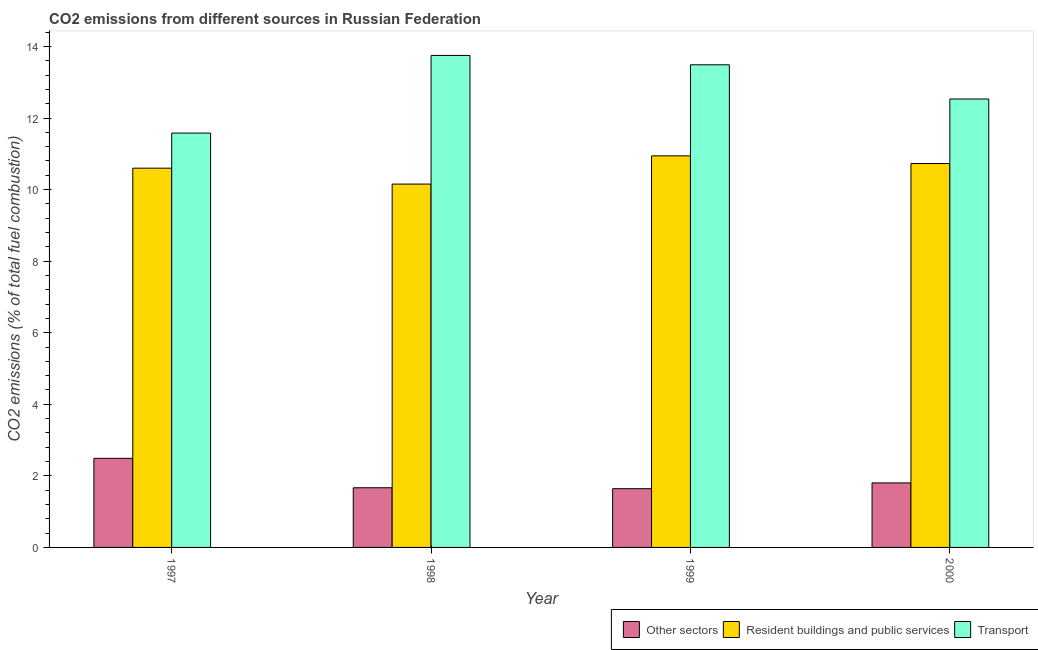How many groups of bars are there?
Your answer should be very brief. 4. How many bars are there on the 3rd tick from the left?
Your response must be concise. 3. How many bars are there on the 2nd tick from the right?
Your answer should be very brief. 3. In how many cases, is the number of bars for a given year not equal to the number of legend labels?
Provide a short and direct response. 0. What is the percentage of co2 emissions from other sectors in 1997?
Keep it short and to the point. 2.49. Across all years, what is the maximum percentage of co2 emissions from transport?
Provide a succinct answer. 13.75. Across all years, what is the minimum percentage of co2 emissions from other sectors?
Provide a succinct answer. 1.64. What is the total percentage of co2 emissions from other sectors in the graph?
Keep it short and to the point. 7.6. What is the difference between the percentage of co2 emissions from resident buildings and public services in 1998 and that in 2000?
Make the answer very short. -0.57. What is the difference between the percentage of co2 emissions from transport in 2000 and the percentage of co2 emissions from resident buildings and public services in 1997?
Keep it short and to the point. 0.95. What is the average percentage of co2 emissions from other sectors per year?
Your answer should be very brief. 1.9. In how many years, is the percentage of co2 emissions from resident buildings and public services greater than 11.6 %?
Offer a terse response. 0. What is the ratio of the percentage of co2 emissions from transport in 1997 to that in 2000?
Give a very brief answer. 0.92. Is the percentage of co2 emissions from other sectors in 1997 less than that in 1998?
Offer a very short reply. No. Is the difference between the percentage of co2 emissions from resident buildings and public services in 1997 and 1998 greater than the difference between the percentage of co2 emissions from transport in 1997 and 1998?
Ensure brevity in your answer.  No. What is the difference between the highest and the second highest percentage of co2 emissions from other sectors?
Your answer should be compact. 0.69. What is the difference between the highest and the lowest percentage of co2 emissions from other sectors?
Ensure brevity in your answer.  0.85. What does the 1st bar from the left in 2000 represents?
Provide a succinct answer. Other sectors. What does the 2nd bar from the right in 2000 represents?
Provide a succinct answer. Resident buildings and public services. Are all the bars in the graph horizontal?
Give a very brief answer. No. How many years are there in the graph?
Provide a succinct answer. 4. Are the values on the major ticks of Y-axis written in scientific E-notation?
Make the answer very short. No. Does the graph contain grids?
Ensure brevity in your answer.  No. Where does the legend appear in the graph?
Make the answer very short. Bottom right. How many legend labels are there?
Offer a very short reply. 3. How are the legend labels stacked?
Ensure brevity in your answer.  Horizontal. What is the title of the graph?
Your answer should be very brief. CO2 emissions from different sources in Russian Federation. What is the label or title of the X-axis?
Offer a terse response. Year. What is the label or title of the Y-axis?
Provide a short and direct response. CO2 emissions (% of total fuel combustion). What is the CO2 emissions (% of total fuel combustion) in Other sectors in 1997?
Your response must be concise. 2.49. What is the CO2 emissions (% of total fuel combustion) of Resident buildings and public services in 1997?
Provide a succinct answer. 10.6. What is the CO2 emissions (% of total fuel combustion) in Transport in 1997?
Give a very brief answer. 11.58. What is the CO2 emissions (% of total fuel combustion) of Other sectors in 1998?
Offer a terse response. 1.67. What is the CO2 emissions (% of total fuel combustion) in Resident buildings and public services in 1998?
Your answer should be compact. 10.15. What is the CO2 emissions (% of total fuel combustion) in Transport in 1998?
Keep it short and to the point. 13.75. What is the CO2 emissions (% of total fuel combustion) in Other sectors in 1999?
Ensure brevity in your answer.  1.64. What is the CO2 emissions (% of total fuel combustion) of Resident buildings and public services in 1999?
Offer a very short reply. 10.94. What is the CO2 emissions (% of total fuel combustion) of Transport in 1999?
Provide a short and direct response. 13.49. What is the CO2 emissions (% of total fuel combustion) of Other sectors in 2000?
Make the answer very short. 1.8. What is the CO2 emissions (% of total fuel combustion) in Resident buildings and public services in 2000?
Provide a short and direct response. 10.73. What is the CO2 emissions (% of total fuel combustion) in Transport in 2000?
Your response must be concise. 12.53. Across all years, what is the maximum CO2 emissions (% of total fuel combustion) in Other sectors?
Your answer should be compact. 2.49. Across all years, what is the maximum CO2 emissions (% of total fuel combustion) of Resident buildings and public services?
Make the answer very short. 10.94. Across all years, what is the maximum CO2 emissions (% of total fuel combustion) of Transport?
Your response must be concise. 13.75. Across all years, what is the minimum CO2 emissions (% of total fuel combustion) of Other sectors?
Ensure brevity in your answer.  1.64. Across all years, what is the minimum CO2 emissions (% of total fuel combustion) of Resident buildings and public services?
Offer a terse response. 10.15. Across all years, what is the minimum CO2 emissions (% of total fuel combustion) of Transport?
Keep it short and to the point. 11.58. What is the total CO2 emissions (% of total fuel combustion) in Other sectors in the graph?
Your answer should be compact. 7.6. What is the total CO2 emissions (% of total fuel combustion) in Resident buildings and public services in the graph?
Make the answer very short. 42.42. What is the total CO2 emissions (% of total fuel combustion) of Transport in the graph?
Offer a very short reply. 51.35. What is the difference between the CO2 emissions (% of total fuel combustion) in Other sectors in 1997 and that in 1998?
Keep it short and to the point. 0.82. What is the difference between the CO2 emissions (% of total fuel combustion) in Resident buildings and public services in 1997 and that in 1998?
Give a very brief answer. 0.44. What is the difference between the CO2 emissions (% of total fuel combustion) in Transport in 1997 and that in 1998?
Offer a terse response. -2.17. What is the difference between the CO2 emissions (% of total fuel combustion) of Other sectors in 1997 and that in 1999?
Your answer should be very brief. 0.85. What is the difference between the CO2 emissions (% of total fuel combustion) in Resident buildings and public services in 1997 and that in 1999?
Offer a terse response. -0.34. What is the difference between the CO2 emissions (% of total fuel combustion) in Transport in 1997 and that in 1999?
Your answer should be compact. -1.91. What is the difference between the CO2 emissions (% of total fuel combustion) of Other sectors in 1997 and that in 2000?
Give a very brief answer. 0.69. What is the difference between the CO2 emissions (% of total fuel combustion) of Resident buildings and public services in 1997 and that in 2000?
Provide a short and direct response. -0.13. What is the difference between the CO2 emissions (% of total fuel combustion) in Transport in 1997 and that in 2000?
Offer a terse response. -0.95. What is the difference between the CO2 emissions (% of total fuel combustion) of Other sectors in 1998 and that in 1999?
Your response must be concise. 0.03. What is the difference between the CO2 emissions (% of total fuel combustion) of Resident buildings and public services in 1998 and that in 1999?
Provide a succinct answer. -0.79. What is the difference between the CO2 emissions (% of total fuel combustion) in Transport in 1998 and that in 1999?
Provide a short and direct response. 0.26. What is the difference between the CO2 emissions (% of total fuel combustion) of Other sectors in 1998 and that in 2000?
Provide a short and direct response. -0.14. What is the difference between the CO2 emissions (% of total fuel combustion) of Resident buildings and public services in 1998 and that in 2000?
Provide a short and direct response. -0.57. What is the difference between the CO2 emissions (% of total fuel combustion) in Transport in 1998 and that in 2000?
Your response must be concise. 1.22. What is the difference between the CO2 emissions (% of total fuel combustion) in Other sectors in 1999 and that in 2000?
Keep it short and to the point. -0.16. What is the difference between the CO2 emissions (% of total fuel combustion) in Resident buildings and public services in 1999 and that in 2000?
Ensure brevity in your answer.  0.21. What is the difference between the CO2 emissions (% of total fuel combustion) of Transport in 1999 and that in 2000?
Ensure brevity in your answer.  0.96. What is the difference between the CO2 emissions (% of total fuel combustion) in Other sectors in 1997 and the CO2 emissions (% of total fuel combustion) in Resident buildings and public services in 1998?
Your response must be concise. -7.66. What is the difference between the CO2 emissions (% of total fuel combustion) of Other sectors in 1997 and the CO2 emissions (% of total fuel combustion) of Transport in 1998?
Your answer should be very brief. -11.26. What is the difference between the CO2 emissions (% of total fuel combustion) in Resident buildings and public services in 1997 and the CO2 emissions (% of total fuel combustion) in Transport in 1998?
Offer a very short reply. -3.15. What is the difference between the CO2 emissions (% of total fuel combustion) in Other sectors in 1997 and the CO2 emissions (% of total fuel combustion) in Resident buildings and public services in 1999?
Keep it short and to the point. -8.45. What is the difference between the CO2 emissions (% of total fuel combustion) in Other sectors in 1997 and the CO2 emissions (% of total fuel combustion) in Transport in 1999?
Provide a short and direct response. -11. What is the difference between the CO2 emissions (% of total fuel combustion) in Resident buildings and public services in 1997 and the CO2 emissions (% of total fuel combustion) in Transport in 1999?
Ensure brevity in your answer.  -2.89. What is the difference between the CO2 emissions (% of total fuel combustion) in Other sectors in 1997 and the CO2 emissions (% of total fuel combustion) in Resident buildings and public services in 2000?
Give a very brief answer. -8.24. What is the difference between the CO2 emissions (% of total fuel combustion) of Other sectors in 1997 and the CO2 emissions (% of total fuel combustion) of Transport in 2000?
Offer a terse response. -10.04. What is the difference between the CO2 emissions (% of total fuel combustion) in Resident buildings and public services in 1997 and the CO2 emissions (% of total fuel combustion) in Transport in 2000?
Give a very brief answer. -1.93. What is the difference between the CO2 emissions (% of total fuel combustion) of Other sectors in 1998 and the CO2 emissions (% of total fuel combustion) of Resident buildings and public services in 1999?
Offer a terse response. -9.27. What is the difference between the CO2 emissions (% of total fuel combustion) in Other sectors in 1998 and the CO2 emissions (% of total fuel combustion) in Transport in 1999?
Provide a succinct answer. -11.82. What is the difference between the CO2 emissions (% of total fuel combustion) in Resident buildings and public services in 1998 and the CO2 emissions (% of total fuel combustion) in Transport in 1999?
Keep it short and to the point. -3.33. What is the difference between the CO2 emissions (% of total fuel combustion) in Other sectors in 1998 and the CO2 emissions (% of total fuel combustion) in Resident buildings and public services in 2000?
Provide a succinct answer. -9.06. What is the difference between the CO2 emissions (% of total fuel combustion) in Other sectors in 1998 and the CO2 emissions (% of total fuel combustion) in Transport in 2000?
Ensure brevity in your answer.  -10.86. What is the difference between the CO2 emissions (% of total fuel combustion) in Resident buildings and public services in 1998 and the CO2 emissions (% of total fuel combustion) in Transport in 2000?
Ensure brevity in your answer.  -2.38. What is the difference between the CO2 emissions (% of total fuel combustion) of Other sectors in 1999 and the CO2 emissions (% of total fuel combustion) of Resident buildings and public services in 2000?
Provide a succinct answer. -9.09. What is the difference between the CO2 emissions (% of total fuel combustion) of Other sectors in 1999 and the CO2 emissions (% of total fuel combustion) of Transport in 2000?
Give a very brief answer. -10.89. What is the difference between the CO2 emissions (% of total fuel combustion) in Resident buildings and public services in 1999 and the CO2 emissions (% of total fuel combustion) in Transport in 2000?
Your answer should be compact. -1.59. What is the average CO2 emissions (% of total fuel combustion) of Other sectors per year?
Your answer should be very brief. 1.9. What is the average CO2 emissions (% of total fuel combustion) in Resident buildings and public services per year?
Provide a short and direct response. 10.61. What is the average CO2 emissions (% of total fuel combustion) in Transport per year?
Your answer should be very brief. 12.84. In the year 1997, what is the difference between the CO2 emissions (% of total fuel combustion) of Other sectors and CO2 emissions (% of total fuel combustion) of Resident buildings and public services?
Your answer should be compact. -8.11. In the year 1997, what is the difference between the CO2 emissions (% of total fuel combustion) in Other sectors and CO2 emissions (% of total fuel combustion) in Transport?
Offer a very short reply. -9.09. In the year 1997, what is the difference between the CO2 emissions (% of total fuel combustion) of Resident buildings and public services and CO2 emissions (% of total fuel combustion) of Transport?
Provide a succinct answer. -0.98. In the year 1998, what is the difference between the CO2 emissions (% of total fuel combustion) of Other sectors and CO2 emissions (% of total fuel combustion) of Resident buildings and public services?
Your response must be concise. -8.49. In the year 1998, what is the difference between the CO2 emissions (% of total fuel combustion) of Other sectors and CO2 emissions (% of total fuel combustion) of Transport?
Give a very brief answer. -12.08. In the year 1998, what is the difference between the CO2 emissions (% of total fuel combustion) of Resident buildings and public services and CO2 emissions (% of total fuel combustion) of Transport?
Ensure brevity in your answer.  -3.6. In the year 1999, what is the difference between the CO2 emissions (% of total fuel combustion) in Other sectors and CO2 emissions (% of total fuel combustion) in Resident buildings and public services?
Offer a very short reply. -9.3. In the year 1999, what is the difference between the CO2 emissions (% of total fuel combustion) in Other sectors and CO2 emissions (% of total fuel combustion) in Transport?
Your response must be concise. -11.85. In the year 1999, what is the difference between the CO2 emissions (% of total fuel combustion) in Resident buildings and public services and CO2 emissions (% of total fuel combustion) in Transport?
Offer a very short reply. -2.54. In the year 2000, what is the difference between the CO2 emissions (% of total fuel combustion) in Other sectors and CO2 emissions (% of total fuel combustion) in Resident buildings and public services?
Keep it short and to the point. -8.92. In the year 2000, what is the difference between the CO2 emissions (% of total fuel combustion) of Other sectors and CO2 emissions (% of total fuel combustion) of Transport?
Give a very brief answer. -10.73. In the year 2000, what is the difference between the CO2 emissions (% of total fuel combustion) of Resident buildings and public services and CO2 emissions (% of total fuel combustion) of Transport?
Offer a very short reply. -1.8. What is the ratio of the CO2 emissions (% of total fuel combustion) of Other sectors in 1997 to that in 1998?
Provide a succinct answer. 1.49. What is the ratio of the CO2 emissions (% of total fuel combustion) of Resident buildings and public services in 1997 to that in 1998?
Make the answer very short. 1.04. What is the ratio of the CO2 emissions (% of total fuel combustion) in Transport in 1997 to that in 1998?
Make the answer very short. 0.84. What is the ratio of the CO2 emissions (% of total fuel combustion) in Other sectors in 1997 to that in 1999?
Provide a succinct answer. 1.52. What is the ratio of the CO2 emissions (% of total fuel combustion) in Resident buildings and public services in 1997 to that in 1999?
Your answer should be compact. 0.97. What is the ratio of the CO2 emissions (% of total fuel combustion) of Transport in 1997 to that in 1999?
Provide a succinct answer. 0.86. What is the ratio of the CO2 emissions (% of total fuel combustion) of Other sectors in 1997 to that in 2000?
Your answer should be compact. 1.38. What is the ratio of the CO2 emissions (% of total fuel combustion) of Resident buildings and public services in 1997 to that in 2000?
Your answer should be compact. 0.99. What is the ratio of the CO2 emissions (% of total fuel combustion) of Transport in 1997 to that in 2000?
Offer a very short reply. 0.92. What is the ratio of the CO2 emissions (% of total fuel combustion) of Other sectors in 1998 to that in 1999?
Your response must be concise. 1.02. What is the ratio of the CO2 emissions (% of total fuel combustion) of Resident buildings and public services in 1998 to that in 1999?
Your response must be concise. 0.93. What is the ratio of the CO2 emissions (% of total fuel combustion) in Transport in 1998 to that in 1999?
Your answer should be compact. 1.02. What is the ratio of the CO2 emissions (% of total fuel combustion) of Other sectors in 1998 to that in 2000?
Ensure brevity in your answer.  0.92. What is the ratio of the CO2 emissions (% of total fuel combustion) of Resident buildings and public services in 1998 to that in 2000?
Provide a short and direct response. 0.95. What is the ratio of the CO2 emissions (% of total fuel combustion) in Transport in 1998 to that in 2000?
Offer a terse response. 1.1. What is the ratio of the CO2 emissions (% of total fuel combustion) of Other sectors in 1999 to that in 2000?
Keep it short and to the point. 0.91. What is the ratio of the CO2 emissions (% of total fuel combustion) in Resident buildings and public services in 1999 to that in 2000?
Your response must be concise. 1.02. What is the ratio of the CO2 emissions (% of total fuel combustion) in Transport in 1999 to that in 2000?
Your response must be concise. 1.08. What is the difference between the highest and the second highest CO2 emissions (% of total fuel combustion) in Other sectors?
Give a very brief answer. 0.69. What is the difference between the highest and the second highest CO2 emissions (% of total fuel combustion) of Resident buildings and public services?
Your answer should be compact. 0.21. What is the difference between the highest and the second highest CO2 emissions (% of total fuel combustion) of Transport?
Offer a very short reply. 0.26. What is the difference between the highest and the lowest CO2 emissions (% of total fuel combustion) of Other sectors?
Your answer should be compact. 0.85. What is the difference between the highest and the lowest CO2 emissions (% of total fuel combustion) of Resident buildings and public services?
Keep it short and to the point. 0.79. What is the difference between the highest and the lowest CO2 emissions (% of total fuel combustion) of Transport?
Offer a very short reply. 2.17. 